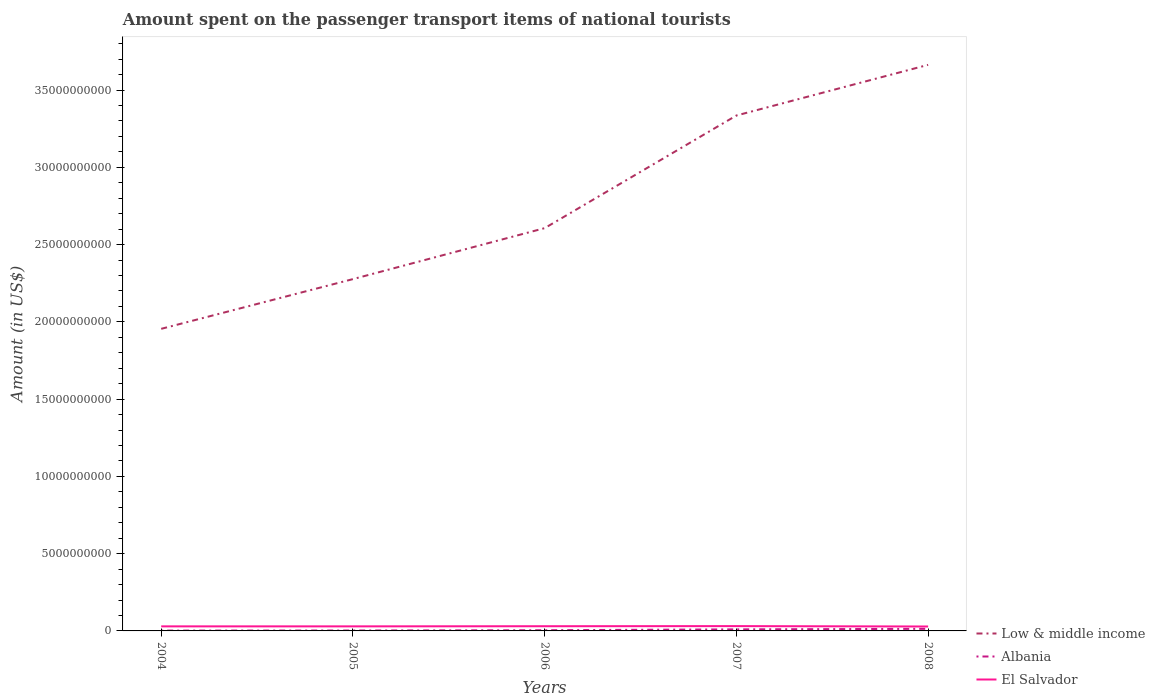Across all years, what is the maximum amount spent on the passenger transport items of national tourists in El Salvador?
Ensure brevity in your answer.  2.86e+08. What is the total amount spent on the passenger transport items of national tourists in Albania in the graph?
Ensure brevity in your answer.  -5.00e+06. What is the difference between the highest and the second highest amount spent on the passenger transport items of national tourists in El Salvador?
Give a very brief answer. 2.50e+07. What is the difference between the highest and the lowest amount spent on the passenger transport items of national tourists in El Salvador?
Provide a succinct answer. 2. How many lines are there?
Provide a short and direct response. 3. How many years are there in the graph?
Ensure brevity in your answer.  5. What is the difference between two consecutive major ticks on the Y-axis?
Give a very brief answer. 5.00e+09. Does the graph contain any zero values?
Give a very brief answer. No. Where does the legend appear in the graph?
Ensure brevity in your answer.  Bottom right. How are the legend labels stacked?
Your response must be concise. Vertical. What is the title of the graph?
Keep it short and to the point. Amount spent on the passenger transport items of national tourists. What is the Amount (in US$) of Low & middle income in 2004?
Your response must be concise. 1.95e+1. What is the Amount (in US$) of Albania in 2004?
Your answer should be very brief. 2.10e+07. What is the Amount (in US$) of El Salvador in 2004?
Your answer should be compact. 2.95e+08. What is the Amount (in US$) of Low & middle income in 2005?
Offer a very short reply. 2.28e+1. What is the Amount (in US$) of Albania in 2005?
Give a very brief answer. 2.60e+07. What is the Amount (in US$) of El Salvador in 2005?
Offer a terse response. 2.95e+08. What is the Amount (in US$) of Low & middle income in 2006?
Give a very brief answer. 2.61e+1. What is the Amount (in US$) of Albania in 2006?
Your response must be concise. 4.50e+07. What is the Amount (in US$) in El Salvador in 2006?
Ensure brevity in your answer.  3.04e+08. What is the Amount (in US$) of Low & middle income in 2007?
Make the answer very short. 3.34e+1. What is the Amount (in US$) of Albania in 2007?
Make the answer very short. 1.01e+08. What is the Amount (in US$) in El Salvador in 2007?
Offer a terse response. 3.11e+08. What is the Amount (in US$) of Low & middle income in 2008?
Your response must be concise. 3.66e+1. What is the Amount (in US$) of Albania in 2008?
Your answer should be very brief. 1.35e+08. What is the Amount (in US$) of El Salvador in 2008?
Give a very brief answer. 2.86e+08. Across all years, what is the maximum Amount (in US$) in Low & middle income?
Your answer should be very brief. 3.66e+1. Across all years, what is the maximum Amount (in US$) in Albania?
Give a very brief answer. 1.35e+08. Across all years, what is the maximum Amount (in US$) in El Salvador?
Offer a very short reply. 3.11e+08. Across all years, what is the minimum Amount (in US$) in Low & middle income?
Ensure brevity in your answer.  1.95e+1. Across all years, what is the minimum Amount (in US$) of Albania?
Provide a short and direct response. 2.10e+07. Across all years, what is the minimum Amount (in US$) of El Salvador?
Provide a short and direct response. 2.86e+08. What is the total Amount (in US$) in Low & middle income in the graph?
Provide a short and direct response. 1.38e+11. What is the total Amount (in US$) in Albania in the graph?
Make the answer very short. 3.28e+08. What is the total Amount (in US$) of El Salvador in the graph?
Give a very brief answer. 1.49e+09. What is the difference between the Amount (in US$) of Low & middle income in 2004 and that in 2005?
Offer a very short reply. -3.22e+09. What is the difference between the Amount (in US$) in Albania in 2004 and that in 2005?
Make the answer very short. -5.00e+06. What is the difference between the Amount (in US$) in El Salvador in 2004 and that in 2005?
Your answer should be compact. 0. What is the difference between the Amount (in US$) in Low & middle income in 2004 and that in 2006?
Provide a succinct answer. -6.52e+09. What is the difference between the Amount (in US$) of Albania in 2004 and that in 2006?
Give a very brief answer. -2.40e+07. What is the difference between the Amount (in US$) of El Salvador in 2004 and that in 2006?
Your response must be concise. -9.00e+06. What is the difference between the Amount (in US$) of Low & middle income in 2004 and that in 2007?
Provide a succinct answer. -1.38e+1. What is the difference between the Amount (in US$) in Albania in 2004 and that in 2007?
Offer a very short reply. -8.00e+07. What is the difference between the Amount (in US$) of El Salvador in 2004 and that in 2007?
Keep it short and to the point. -1.60e+07. What is the difference between the Amount (in US$) in Low & middle income in 2004 and that in 2008?
Offer a very short reply. -1.71e+1. What is the difference between the Amount (in US$) of Albania in 2004 and that in 2008?
Offer a very short reply. -1.14e+08. What is the difference between the Amount (in US$) of El Salvador in 2004 and that in 2008?
Provide a short and direct response. 9.00e+06. What is the difference between the Amount (in US$) of Low & middle income in 2005 and that in 2006?
Provide a short and direct response. -3.30e+09. What is the difference between the Amount (in US$) of Albania in 2005 and that in 2006?
Provide a short and direct response. -1.90e+07. What is the difference between the Amount (in US$) of El Salvador in 2005 and that in 2006?
Your response must be concise. -9.00e+06. What is the difference between the Amount (in US$) in Low & middle income in 2005 and that in 2007?
Provide a short and direct response. -1.06e+1. What is the difference between the Amount (in US$) in Albania in 2005 and that in 2007?
Provide a short and direct response. -7.50e+07. What is the difference between the Amount (in US$) in El Salvador in 2005 and that in 2007?
Offer a terse response. -1.60e+07. What is the difference between the Amount (in US$) in Low & middle income in 2005 and that in 2008?
Your response must be concise. -1.39e+1. What is the difference between the Amount (in US$) in Albania in 2005 and that in 2008?
Provide a short and direct response. -1.09e+08. What is the difference between the Amount (in US$) in El Salvador in 2005 and that in 2008?
Provide a short and direct response. 9.00e+06. What is the difference between the Amount (in US$) of Low & middle income in 2006 and that in 2007?
Ensure brevity in your answer.  -7.29e+09. What is the difference between the Amount (in US$) of Albania in 2006 and that in 2007?
Your response must be concise. -5.60e+07. What is the difference between the Amount (in US$) of El Salvador in 2006 and that in 2007?
Keep it short and to the point. -7.00e+06. What is the difference between the Amount (in US$) of Low & middle income in 2006 and that in 2008?
Provide a succinct answer. -1.06e+1. What is the difference between the Amount (in US$) in Albania in 2006 and that in 2008?
Offer a terse response. -9.00e+07. What is the difference between the Amount (in US$) of El Salvador in 2006 and that in 2008?
Ensure brevity in your answer.  1.80e+07. What is the difference between the Amount (in US$) of Low & middle income in 2007 and that in 2008?
Provide a short and direct response. -3.28e+09. What is the difference between the Amount (in US$) of Albania in 2007 and that in 2008?
Your answer should be compact. -3.40e+07. What is the difference between the Amount (in US$) of El Salvador in 2007 and that in 2008?
Your answer should be compact. 2.50e+07. What is the difference between the Amount (in US$) of Low & middle income in 2004 and the Amount (in US$) of Albania in 2005?
Your response must be concise. 1.95e+1. What is the difference between the Amount (in US$) of Low & middle income in 2004 and the Amount (in US$) of El Salvador in 2005?
Your answer should be compact. 1.93e+1. What is the difference between the Amount (in US$) in Albania in 2004 and the Amount (in US$) in El Salvador in 2005?
Provide a short and direct response. -2.74e+08. What is the difference between the Amount (in US$) of Low & middle income in 2004 and the Amount (in US$) of Albania in 2006?
Your answer should be very brief. 1.95e+1. What is the difference between the Amount (in US$) of Low & middle income in 2004 and the Amount (in US$) of El Salvador in 2006?
Offer a terse response. 1.92e+1. What is the difference between the Amount (in US$) in Albania in 2004 and the Amount (in US$) in El Salvador in 2006?
Offer a terse response. -2.83e+08. What is the difference between the Amount (in US$) of Low & middle income in 2004 and the Amount (in US$) of Albania in 2007?
Your answer should be very brief. 1.94e+1. What is the difference between the Amount (in US$) in Low & middle income in 2004 and the Amount (in US$) in El Salvador in 2007?
Your response must be concise. 1.92e+1. What is the difference between the Amount (in US$) of Albania in 2004 and the Amount (in US$) of El Salvador in 2007?
Offer a very short reply. -2.90e+08. What is the difference between the Amount (in US$) of Low & middle income in 2004 and the Amount (in US$) of Albania in 2008?
Your answer should be compact. 1.94e+1. What is the difference between the Amount (in US$) in Low & middle income in 2004 and the Amount (in US$) in El Salvador in 2008?
Your answer should be very brief. 1.93e+1. What is the difference between the Amount (in US$) in Albania in 2004 and the Amount (in US$) in El Salvador in 2008?
Ensure brevity in your answer.  -2.65e+08. What is the difference between the Amount (in US$) of Low & middle income in 2005 and the Amount (in US$) of Albania in 2006?
Provide a short and direct response. 2.27e+1. What is the difference between the Amount (in US$) in Low & middle income in 2005 and the Amount (in US$) in El Salvador in 2006?
Offer a terse response. 2.25e+1. What is the difference between the Amount (in US$) of Albania in 2005 and the Amount (in US$) of El Salvador in 2006?
Keep it short and to the point. -2.78e+08. What is the difference between the Amount (in US$) of Low & middle income in 2005 and the Amount (in US$) of Albania in 2007?
Offer a very short reply. 2.27e+1. What is the difference between the Amount (in US$) of Low & middle income in 2005 and the Amount (in US$) of El Salvador in 2007?
Provide a short and direct response. 2.25e+1. What is the difference between the Amount (in US$) in Albania in 2005 and the Amount (in US$) in El Salvador in 2007?
Make the answer very short. -2.85e+08. What is the difference between the Amount (in US$) in Low & middle income in 2005 and the Amount (in US$) in Albania in 2008?
Provide a short and direct response. 2.26e+1. What is the difference between the Amount (in US$) in Low & middle income in 2005 and the Amount (in US$) in El Salvador in 2008?
Offer a very short reply. 2.25e+1. What is the difference between the Amount (in US$) in Albania in 2005 and the Amount (in US$) in El Salvador in 2008?
Keep it short and to the point. -2.60e+08. What is the difference between the Amount (in US$) in Low & middle income in 2006 and the Amount (in US$) in Albania in 2007?
Provide a succinct answer. 2.60e+1. What is the difference between the Amount (in US$) of Low & middle income in 2006 and the Amount (in US$) of El Salvador in 2007?
Offer a very short reply. 2.58e+1. What is the difference between the Amount (in US$) of Albania in 2006 and the Amount (in US$) of El Salvador in 2007?
Make the answer very short. -2.66e+08. What is the difference between the Amount (in US$) in Low & middle income in 2006 and the Amount (in US$) in Albania in 2008?
Offer a terse response. 2.59e+1. What is the difference between the Amount (in US$) in Low & middle income in 2006 and the Amount (in US$) in El Salvador in 2008?
Your answer should be compact. 2.58e+1. What is the difference between the Amount (in US$) in Albania in 2006 and the Amount (in US$) in El Salvador in 2008?
Ensure brevity in your answer.  -2.41e+08. What is the difference between the Amount (in US$) in Low & middle income in 2007 and the Amount (in US$) in Albania in 2008?
Your answer should be compact. 3.32e+1. What is the difference between the Amount (in US$) of Low & middle income in 2007 and the Amount (in US$) of El Salvador in 2008?
Your response must be concise. 3.31e+1. What is the difference between the Amount (in US$) in Albania in 2007 and the Amount (in US$) in El Salvador in 2008?
Keep it short and to the point. -1.85e+08. What is the average Amount (in US$) in Low & middle income per year?
Provide a short and direct response. 2.77e+1. What is the average Amount (in US$) of Albania per year?
Offer a very short reply. 6.56e+07. What is the average Amount (in US$) in El Salvador per year?
Keep it short and to the point. 2.98e+08. In the year 2004, what is the difference between the Amount (in US$) of Low & middle income and Amount (in US$) of Albania?
Ensure brevity in your answer.  1.95e+1. In the year 2004, what is the difference between the Amount (in US$) of Low & middle income and Amount (in US$) of El Salvador?
Your response must be concise. 1.93e+1. In the year 2004, what is the difference between the Amount (in US$) in Albania and Amount (in US$) in El Salvador?
Give a very brief answer. -2.74e+08. In the year 2005, what is the difference between the Amount (in US$) of Low & middle income and Amount (in US$) of Albania?
Make the answer very short. 2.27e+1. In the year 2005, what is the difference between the Amount (in US$) of Low & middle income and Amount (in US$) of El Salvador?
Your response must be concise. 2.25e+1. In the year 2005, what is the difference between the Amount (in US$) in Albania and Amount (in US$) in El Salvador?
Your answer should be very brief. -2.69e+08. In the year 2006, what is the difference between the Amount (in US$) of Low & middle income and Amount (in US$) of Albania?
Provide a succinct answer. 2.60e+1. In the year 2006, what is the difference between the Amount (in US$) of Low & middle income and Amount (in US$) of El Salvador?
Make the answer very short. 2.58e+1. In the year 2006, what is the difference between the Amount (in US$) of Albania and Amount (in US$) of El Salvador?
Give a very brief answer. -2.59e+08. In the year 2007, what is the difference between the Amount (in US$) of Low & middle income and Amount (in US$) of Albania?
Provide a short and direct response. 3.33e+1. In the year 2007, what is the difference between the Amount (in US$) in Low & middle income and Amount (in US$) in El Salvador?
Give a very brief answer. 3.30e+1. In the year 2007, what is the difference between the Amount (in US$) of Albania and Amount (in US$) of El Salvador?
Your answer should be compact. -2.10e+08. In the year 2008, what is the difference between the Amount (in US$) in Low & middle income and Amount (in US$) in Albania?
Give a very brief answer. 3.65e+1. In the year 2008, what is the difference between the Amount (in US$) in Low & middle income and Amount (in US$) in El Salvador?
Provide a succinct answer. 3.63e+1. In the year 2008, what is the difference between the Amount (in US$) in Albania and Amount (in US$) in El Salvador?
Keep it short and to the point. -1.51e+08. What is the ratio of the Amount (in US$) in Low & middle income in 2004 to that in 2005?
Provide a short and direct response. 0.86. What is the ratio of the Amount (in US$) in Albania in 2004 to that in 2005?
Your answer should be very brief. 0.81. What is the ratio of the Amount (in US$) of El Salvador in 2004 to that in 2005?
Offer a very short reply. 1. What is the ratio of the Amount (in US$) in Low & middle income in 2004 to that in 2006?
Your answer should be compact. 0.75. What is the ratio of the Amount (in US$) in Albania in 2004 to that in 2006?
Give a very brief answer. 0.47. What is the ratio of the Amount (in US$) in El Salvador in 2004 to that in 2006?
Offer a very short reply. 0.97. What is the ratio of the Amount (in US$) of Low & middle income in 2004 to that in 2007?
Offer a very short reply. 0.59. What is the ratio of the Amount (in US$) in Albania in 2004 to that in 2007?
Keep it short and to the point. 0.21. What is the ratio of the Amount (in US$) of El Salvador in 2004 to that in 2007?
Make the answer very short. 0.95. What is the ratio of the Amount (in US$) in Low & middle income in 2004 to that in 2008?
Give a very brief answer. 0.53. What is the ratio of the Amount (in US$) of Albania in 2004 to that in 2008?
Offer a very short reply. 0.16. What is the ratio of the Amount (in US$) in El Salvador in 2004 to that in 2008?
Make the answer very short. 1.03. What is the ratio of the Amount (in US$) in Low & middle income in 2005 to that in 2006?
Your answer should be compact. 0.87. What is the ratio of the Amount (in US$) of Albania in 2005 to that in 2006?
Keep it short and to the point. 0.58. What is the ratio of the Amount (in US$) of El Salvador in 2005 to that in 2006?
Offer a terse response. 0.97. What is the ratio of the Amount (in US$) of Low & middle income in 2005 to that in 2007?
Offer a very short reply. 0.68. What is the ratio of the Amount (in US$) of Albania in 2005 to that in 2007?
Keep it short and to the point. 0.26. What is the ratio of the Amount (in US$) in El Salvador in 2005 to that in 2007?
Your answer should be compact. 0.95. What is the ratio of the Amount (in US$) in Low & middle income in 2005 to that in 2008?
Offer a terse response. 0.62. What is the ratio of the Amount (in US$) in Albania in 2005 to that in 2008?
Your response must be concise. 0.19. What is the ratio of the Amount (in US$) of El Salvador in 2005 to that in 2008?
Offer a very short reply. 1.03. What is the ratio of the Amount (in US$) of Low & middle income in 2006 to that in 2007?
Make the answer very short. 0.78. What is the ratio of the Amount (in US$) of Albania in 2006 to that in 2007?
Provide a succinct answer. 0.45. What is the ratio of the Amount (in US$) of El Salvador in 2006 to that in 2007?
Your response must be concise. 0.98. What is the ratio of the Amount (in US$) in Low & middle income in 2006 to that in 2008?
Offer a terse response. 0.71. What is the ratio of the Amount (in US$) of El Salvador in 2006 to that in 2008?
Keep it short and to the point. 1.06. What is the ratio of the Amount (in US$) in Low & middle income in 2007 to that in 2008?
Provide a succinct answer. 0.91. What is the ratio of the Amount (in US$) in Albania in 2007 to that in 2008?
Offer a very short reply. 0.75. What is the ratio of the Amount (in US$) in El Salvador in 2007 to that in 2008?
Provide a succinct answer. 1.09. What is the difference between the highest and the second highest Amount (in US$) in Low & middle income?
Your answer should be very brief. 3.28e+09. What is the difference between the highest and the second highest Amount (in US$) in Albania?
Your answer should be very brief. 3.40e+07. What is the difference between the highest and the second highest Amount (in US$) of El Salvador?
Offer a terse response. 7.00e+06. What is the difference between the highest and the lowest Amount (in US$) in Low & middle income?
Your answer should be very brief. 1.71e+1. What is the difference between the highest and the lowest Amount (in US$) in Albania?
Make the answer very short. 1.14e+08. What is the difference between the highest and the lowest Amount (in US$) of El Salvador?
Your answer should be compact. 2.50e+07. 